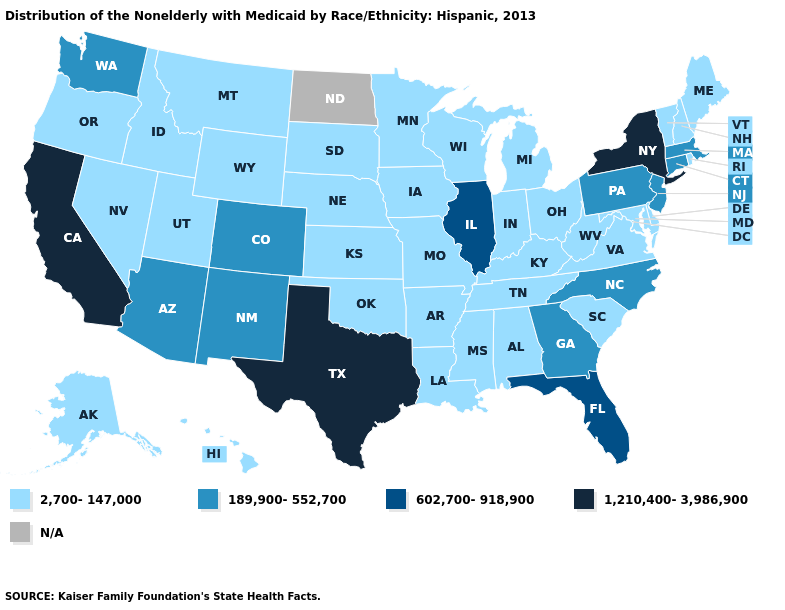Does Texas have the highest value in the USA?
Give a very brief answer. Yes. Which states have the highest value in the USA?
Write a very short answer. California, New York, Texas. What is the value of Alaska?
Short answer required. 2,700-147,000. Name the states that have a value in the range N/A?
Write a very short answer. North Dakota. What is the value of Nebraska?
Give a very brief answer. 2,700-147,000. What is the highest value in the USA?
Give a very brief answer. 1,210,400-3,986,900. Which states have the lowest value in the West?
Quick response, please. Alaska, Hawaii, Idaho, Montana, Nevada, Oregon, Utah, Wyoming. Name the states that have a value in the range 1,210,400-3,986,900?
Answer briefly. California, New York, Texas. What is the value of Massachusetts?
Write a very short answer. 189,900-552,700. What is the value of Florida?
Give a very brief answer. 602,700-918,900. Among the states that border Arkansas , does Texas have the lowest value?
Give a very brief answer. No. Among the states that border Nevada , does California have the lowest value?
Be succinct. No. What is the value of Colorado?
Concise answer only. 189,900-552,700. Among the states that border Wisconsin , does Iowa have the lowest value?
Write a very short answer. Yes. 